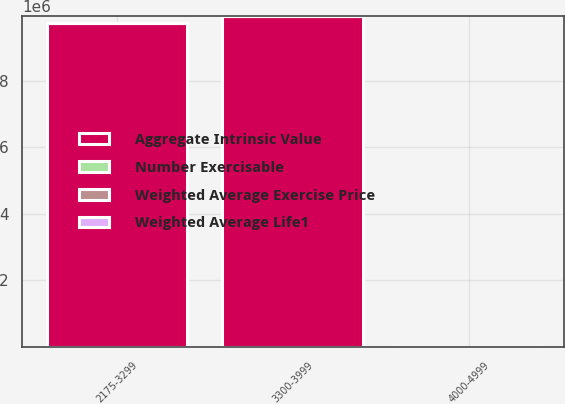Convert chart to OTSL. <chart><loc_0><loc_0><loc_500><loc_500><stacked_bar_chart><ecel><fcel>2175-3299<fcel>3300-3999<fcel>4000-4999<nl><fcel>Aggregate Intrinsic Value<fcel>9.7154e+06<fcel>9.92447e+06<fcel>42.66<nl><fcel>Number Exercisable<fcel>6.87<fcel>2.92<fcel>7.13<nl><fcel>Weighted Average Life1<fcel>27.55<fcel>35.92<fcel>42.66<nl><fcel>Weighted Average Exercise Price<fcel>249<fcel>171<fcel>177<nl></chart> 